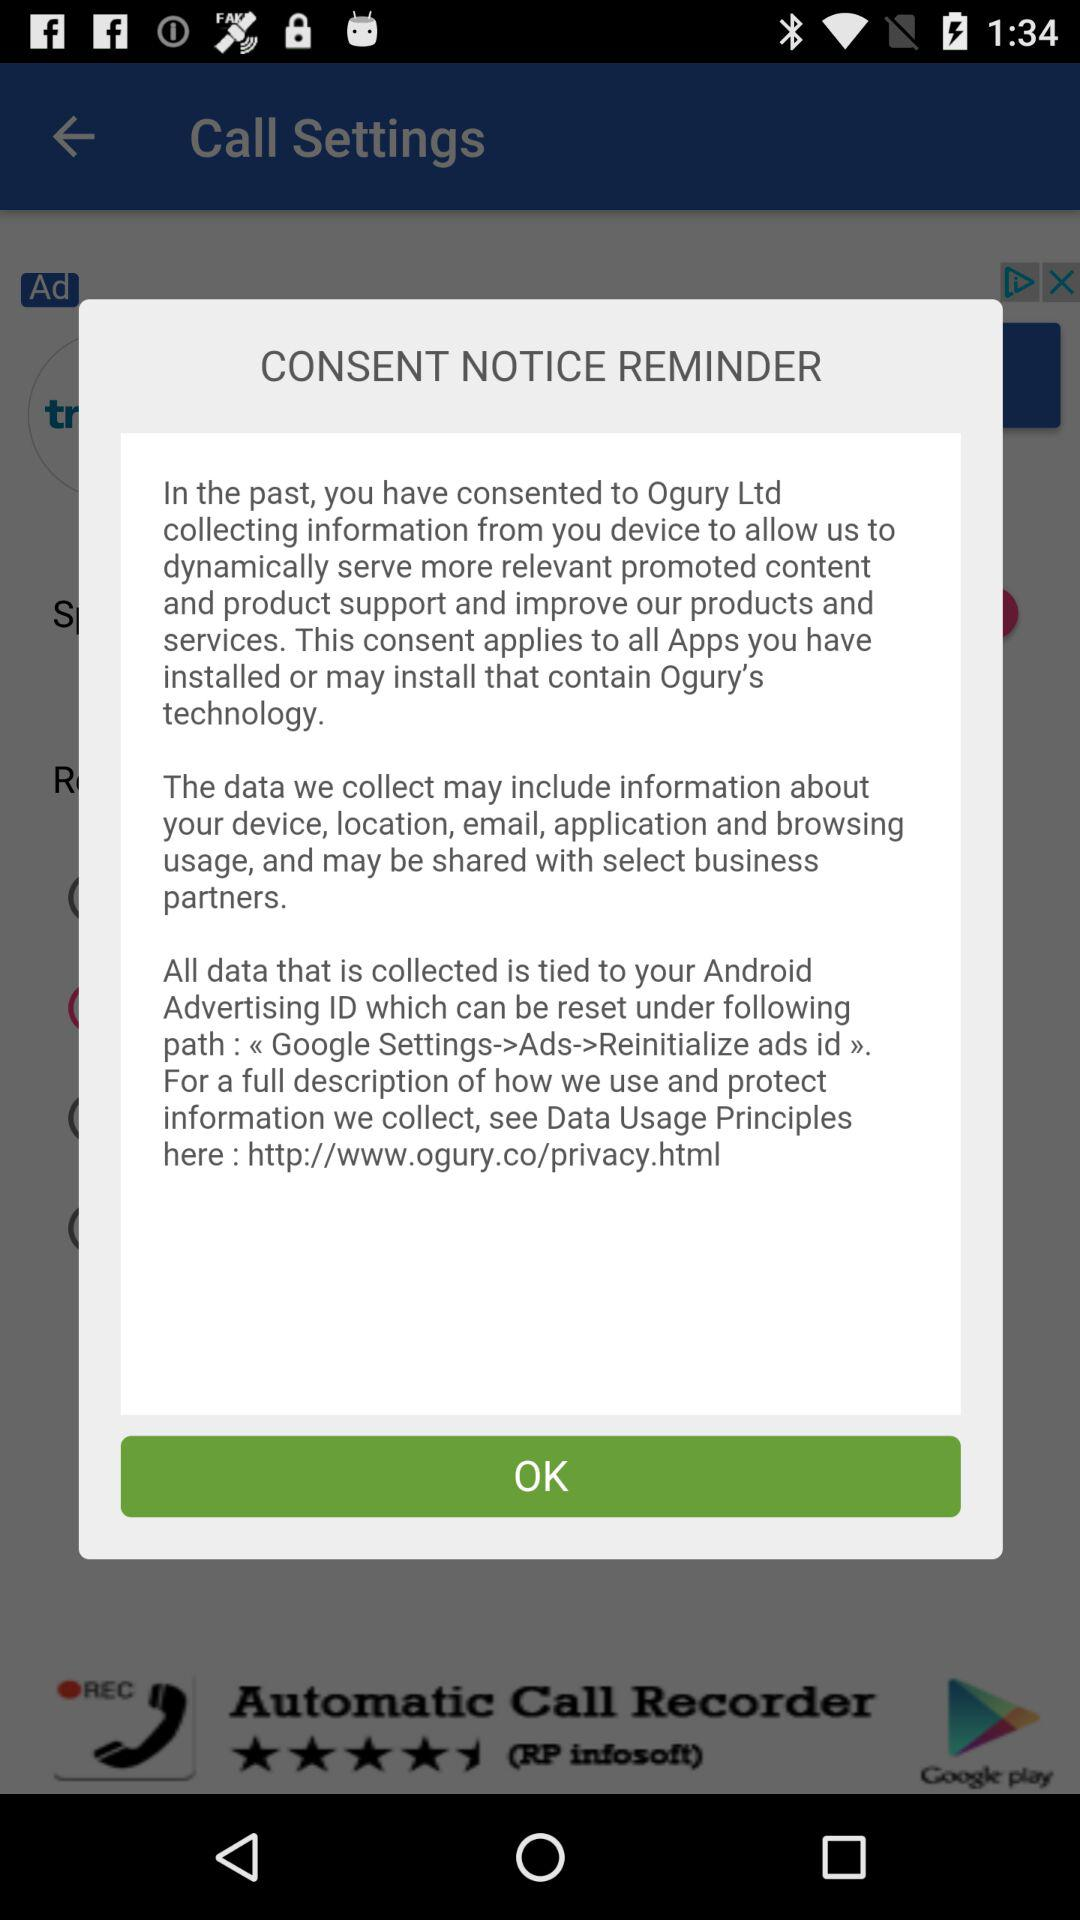What URL address should we use to use and preserve the information we've gathered? You should use http://www.ogury.co/privacy.html to use and preserve the information you have gathered. 